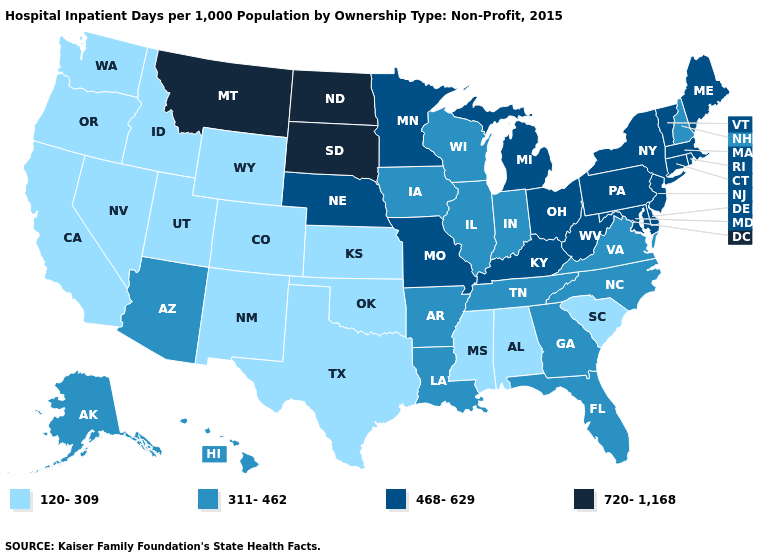Name the states that have a value in the range 120-309?
Short answer required. Alabama, California, Colorado, Idaho, Kansas, Mississippi, Nevada, New Mexico, Oklahoma, Oregon, South Carolina, Texas, Utah, Washington, Wyoming. What is the highest value in the West ?
Answer briefly. 720-1,168. Does Mississippi have the lowest value in the USA?
Concise answer only. Yes. Which states hav the highest value in the West?
Keep it brief. Montana. Name the states that have a value in the range 120-309?
Quick response, please. Alabama, California, Colorado, Idaho, Kansas, Mississippi, Nevada, New Mexico, Oklahoma, Oregon, South Carolina, Texas, Utah, Washington, Wyoming. What is the highest value in the USA?
Answer briefly. 720-1,168. Among the states that border Massachusetts , does New York have the lowest value?
Be succinct. No. What is the value of Massachusetts?
Answer briefly. 468-629. What is the value of Florida?
Answer briefly. 311-462. Does Delaware have the highest value in the South?
Quick response, please. Yes. Does California have a higher value than Kentucky?
Concise answer only. No. What is the highest value in the USA?
Quick response, please. 720-1,168. Does Rhode Island have the highest value in the USA?
Quick response, please. No. Name the states that have a value in the range 120-309?
Give a very brief answer. Alabama, California, Colorado, Idaho, Kansas, Mississippi, Nevada, New Mexico, Oklahoma, Oregon, South Carolina, Texas, Utah, Washington, Wyoming. Does North Dakota have the same value as Iowa?
Quick response, please. No. 